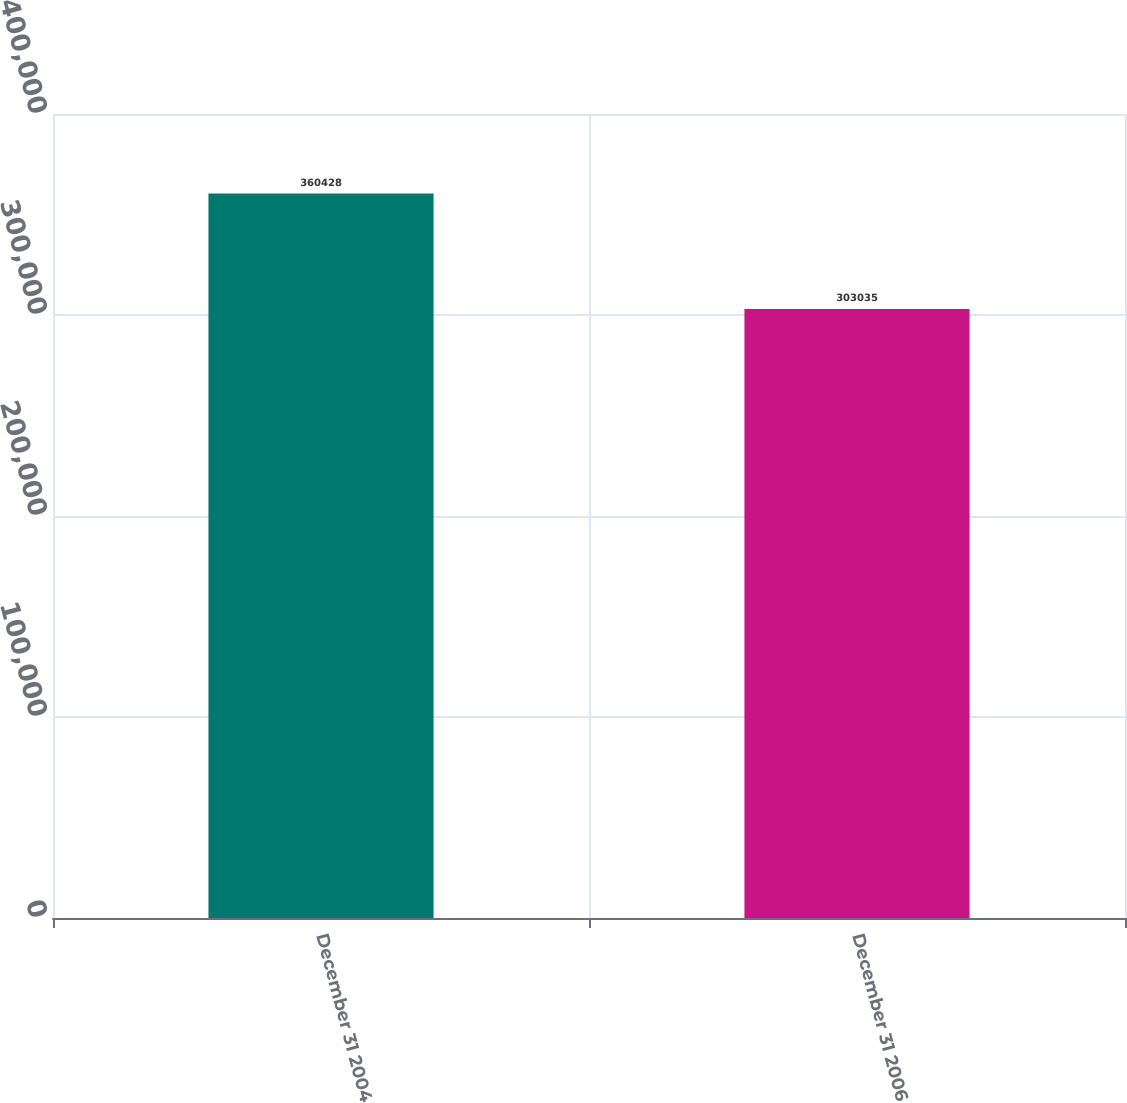<chart> <loc_0><loc_0><loc_500><loc_500><bar_chart><fcel>December 31 2004<fcel>December 31 2006<nl><fcel>360428<fcel>303035<nl></chart> 